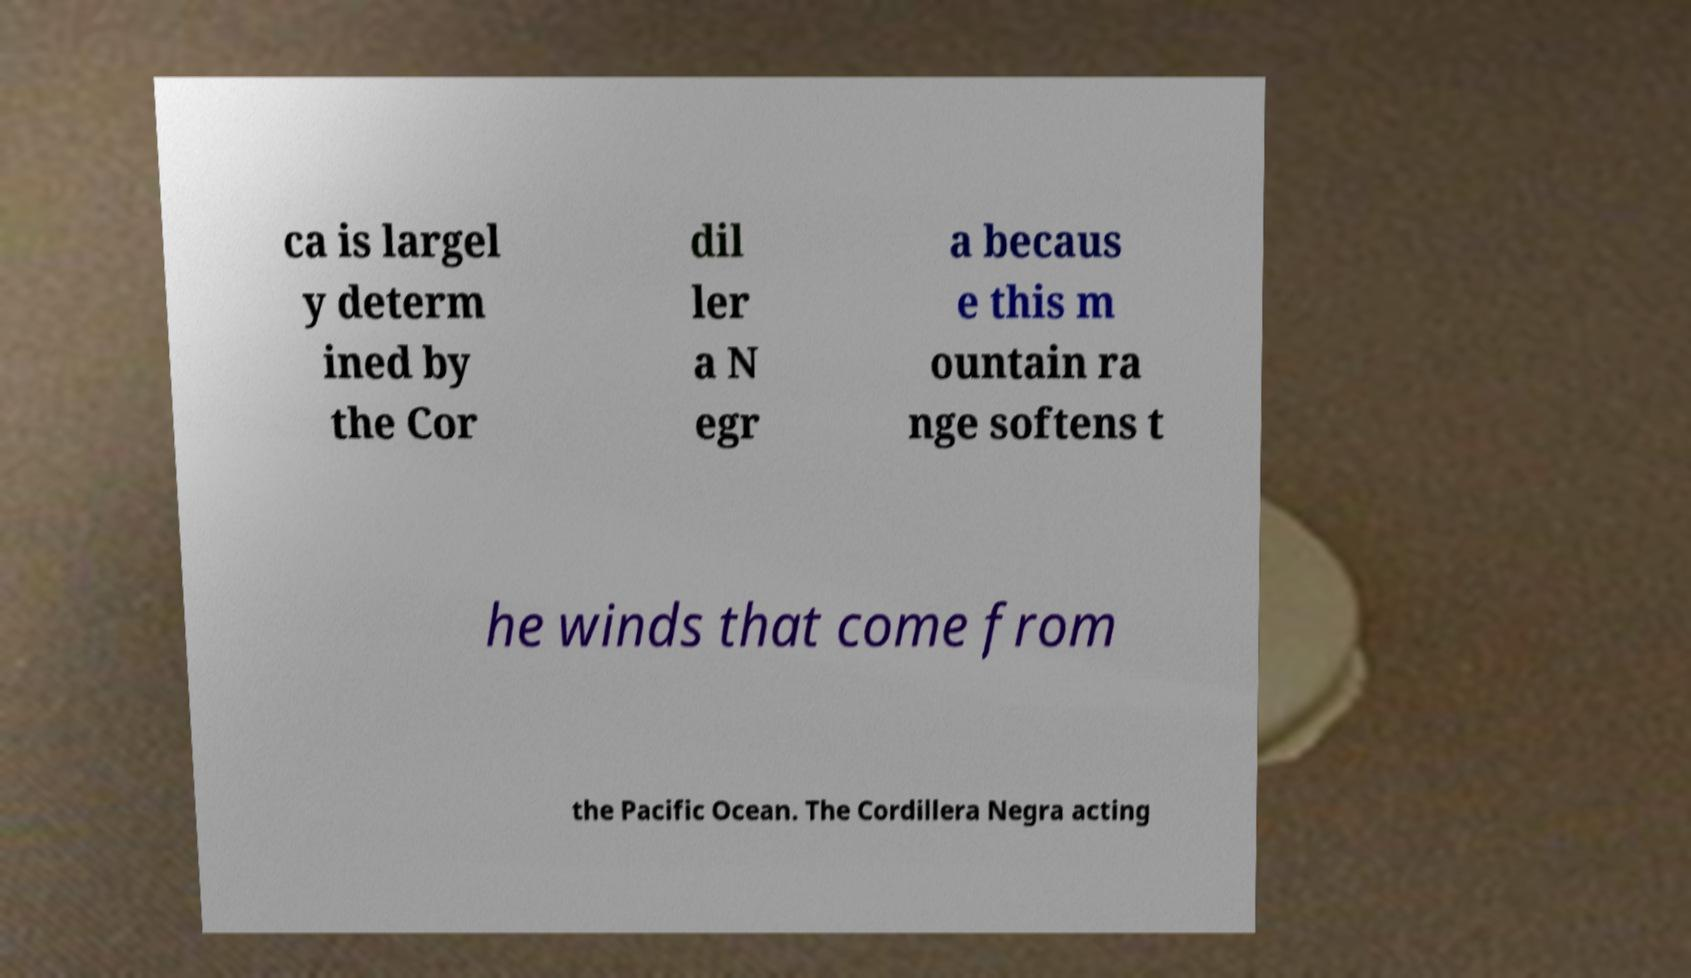Could you extract and type out the text from this image? ca is largel y determ ined by the Cor dil ler a N egr a becaus e this m ountain ra nge softens t he winds that come from the Pacific Ocean. The Cordillera Negra acting 